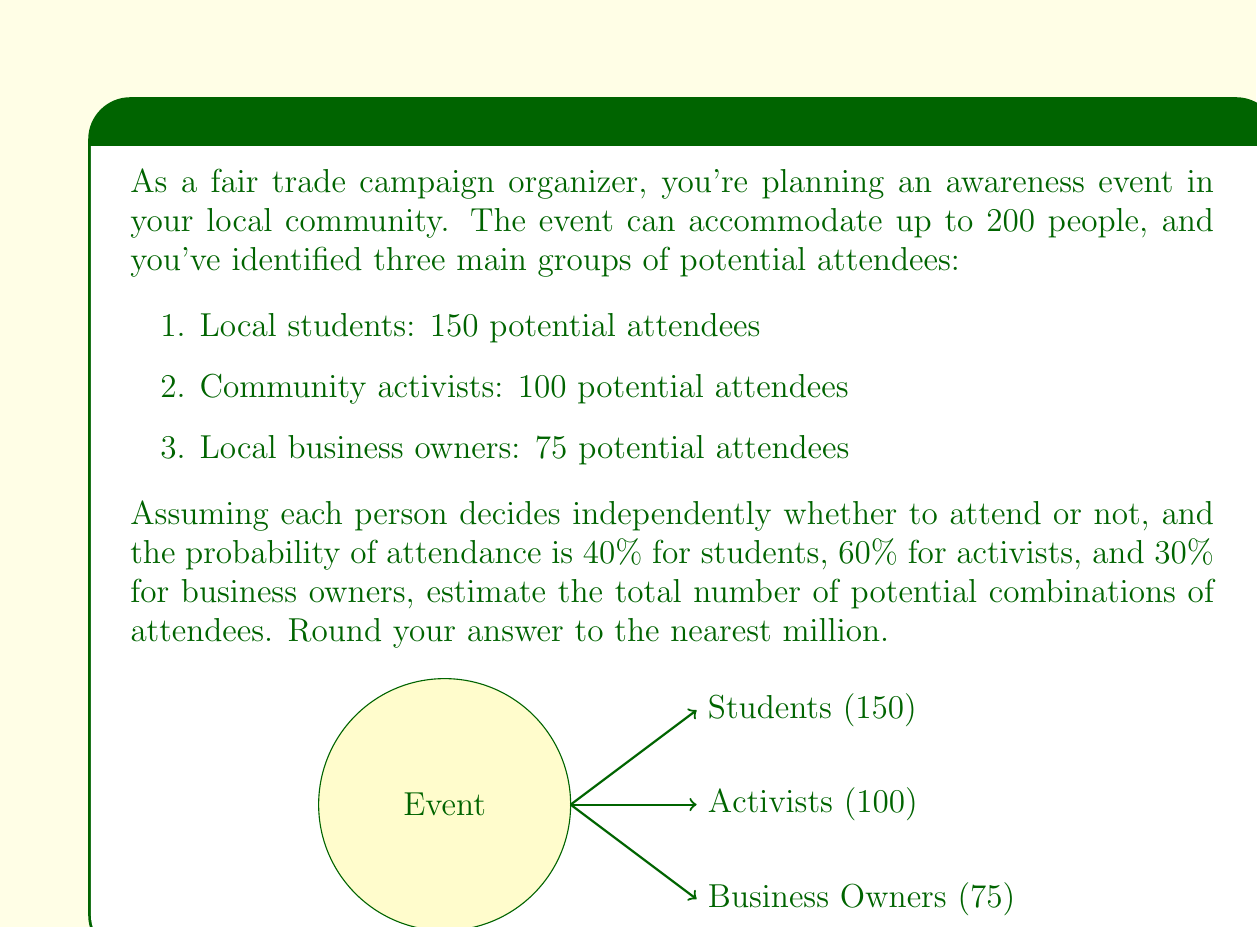Help me with this question. Let's approach this problem step-by-step using combinatorial principles:

1) For each group, we need to calculate the number of ways to choose attendees:

   a) Students: Each student can either attend or not attend. This is equivalent to choosing from 150 students with a binomial distribution. The number of ways is $2^{150}$.

   b) Activists: Similarly, for 100 activists, we have $2^{100}$ possibilities.

   c) Business owners: For 75 business owners, we have $2^{75}$ possibilities.

2) The total number of combinations is the product of these individual combinations:

   $$ \text{Total combinations} = 2^{150} \times 2^{100} \times 2^{75} = 2^{325} $$

3) To calculate this:
   
   $2^{325} \approx 5.638 \times 10^{97}$

4) Rounding to the nearest million:

   $5,638,000,000,000,000,000,000,000,000,000,000,000,000,000,000,000,000,000,000,000,000,000,000,000,000,000,000,000,000,000,000,000,000$

Note: This calculation assumes all combinations are possible, including having more than 200 attendees. In reality, the event's capacity would limit the actual number of combinations, but calculating that would require more complex combinatorics beyond the scope of this problem.
Answer: $5.638 \times 10^{97}$ combinations 